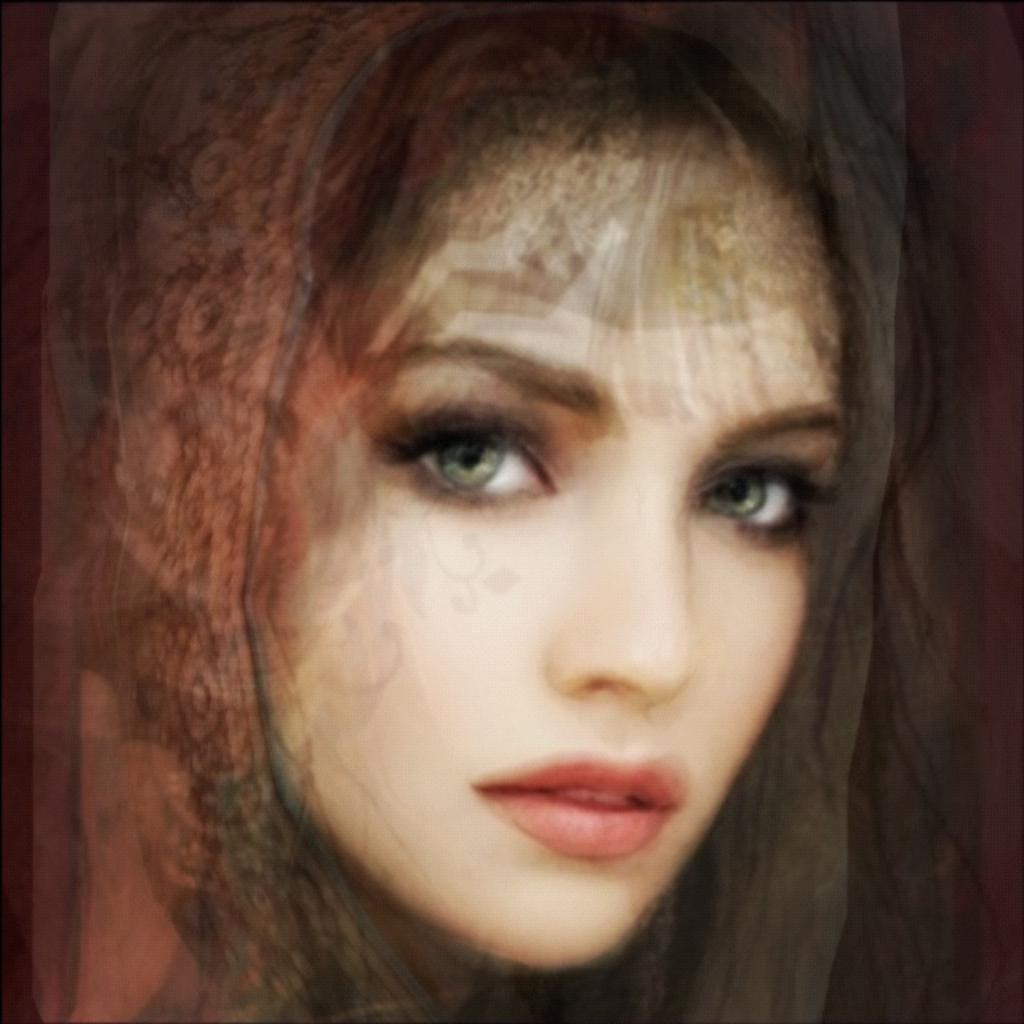What style is the image presented in? The image looks like a painting. What specific detail can be observed in the painting? There are red lips depicted in the image. What type of cake is being served in the image? There is no cake present in the image; it is a painting with red lips depicted. What does the image need to be considered complete? The image is already complete as it is a painting, and there is no need for additional elements. 